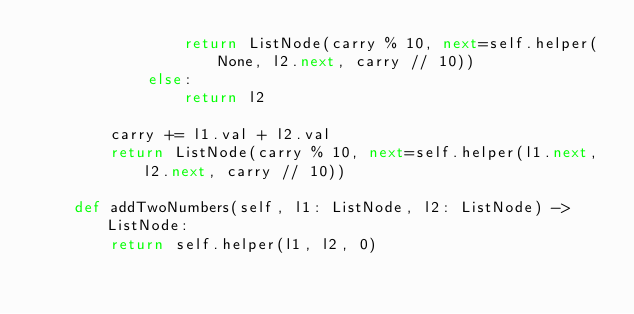<code> <loc_0><loc_0><loc_500><loc_500><_Python_>                return ListNode(carry % 10, next=self.helper(None, l2.next, carry // 10))
            else:
                return l2

        carry += l1.val + l2.val
        return ListNode(carry % 10, next=self.helper(l1.next, l2.next, carry // 10))

    def addTwoNumbers(self, l1: ListNode, l2: ListNode) -> ListNode:
        return self.helper(l1, l2, 0)
</code> 